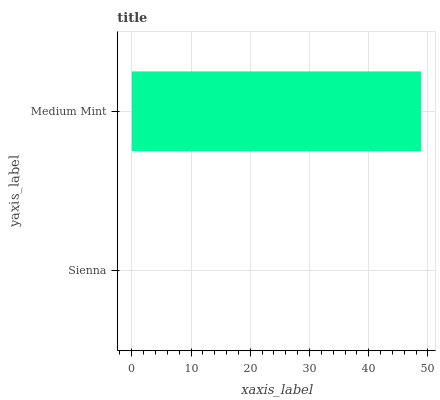Is Sienna the minimum?
Answer yes or no. Yes. Is Medium Mint the maximum?
Answer yes or no. Yes. Is Medium Mint the minimum?
Answer yes or no. No. Is Medium Mint greater than Sienna?
Answer yes or no. Yes. Is Sienna less than Medium Mint?
Answer yes or no. Yes. Is Sienna greater than Medium Mint?
Answer yes or no. No. Is Medium Mint less than Sienna?
Answer yes or no. No. Is Medium Mint the high median?
Answer yes or no. Yes. Is Sienna the low median?
Answer yes or no. Yes. Is Sienna the high median?
Answer yes or no. No. Is Medium Mint the low median?
Answer yes or no. No. 